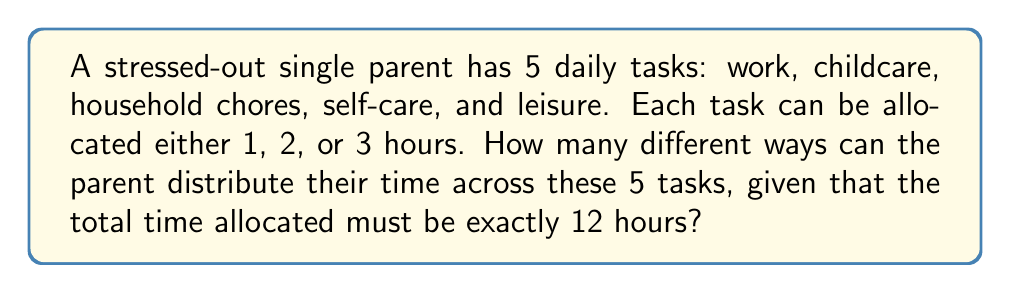Show me your answer to this math problem. Let's approach this step-by-step:

1) This is a combinatorics problem involving distributions with constraints. We can use the stars and bars method with some modifications.

2) We have 5 tasks (n = 5) and 12 hours to distribute (k = 12).

3) However, each task must be allocated at least 1 hour and at most 3 hours. This changes our approach slightly.

4) Let's define variables $x_1, x_2, x_3, x_4, x_5$ for each task. We need:

   $$x_1 + x_2 + x_3 + x_4 + x_5 = 12$$
   
   where $1 \leq x_i \leq 3$ for all i.

5) To solve this, let's introduce new variables:
   
   $y_i = x_i - 1$ for all i

6) Now our equation becomes:

   $$(y_1 + 1) + (y_2 + 1) + (y_3 + 1) + (y_4 + 1) + (y_5 + 1) = 12$$

   Simplifying: $y_1 + y_2 + y_3 + y_4 + y_5 = 7$

   where $0 \leq y_i \leq 2$ for all i.

7) This is now a standard stars and bars problem with 5 variables, sum of 7, and each variable limited to 0, 1, or 2.

8) We can solve this using the Principle of Inclusion-Exclusion (PIE):

   Let A be the set of all solutions where each $y_i \leq 2$.
   Let $B_i$ be the set of solutions where $y_i \geq 3$.

   $$|A| = \binom{7+5-1}{5-1} - \binom{5}{1}\binom{4+5-1}{5-1} + \binom{5}{2}\binom{1+5-1}{5-1}$$

9) Calculating:
   
   $$|A| = \binom{11}{4} - 5\binom{8}{4} + 10\binom{5}{4}$$
   $$= 330 - 5(70) + 10(5) = 330 - 350 + 50 = 30$$

Therefore, there are 30 different ways for the parent to distribute their time.
Answer: 30 